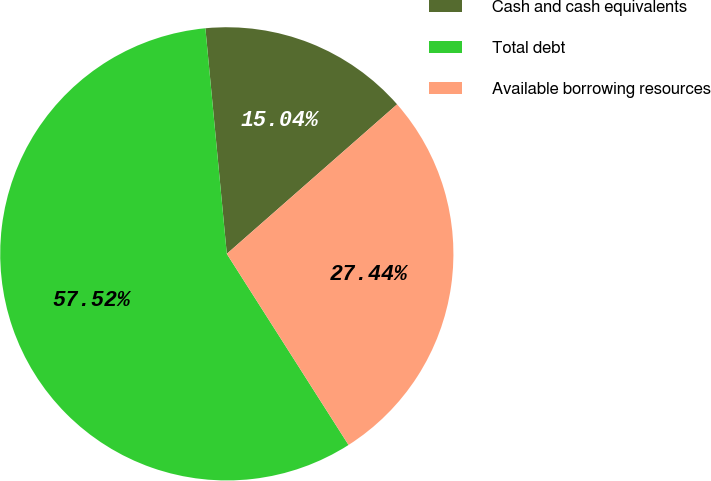Convert chart. <chart><loc_0><loc_0><loc_500><loc_500><pie_chart><fcel>Cash and cash equivalents<fcel>Total debt<fcel>Available borrowing resources<nl><fcel>15.04%<fcel>57.52%<fcel>27.44%<nl></chart> 